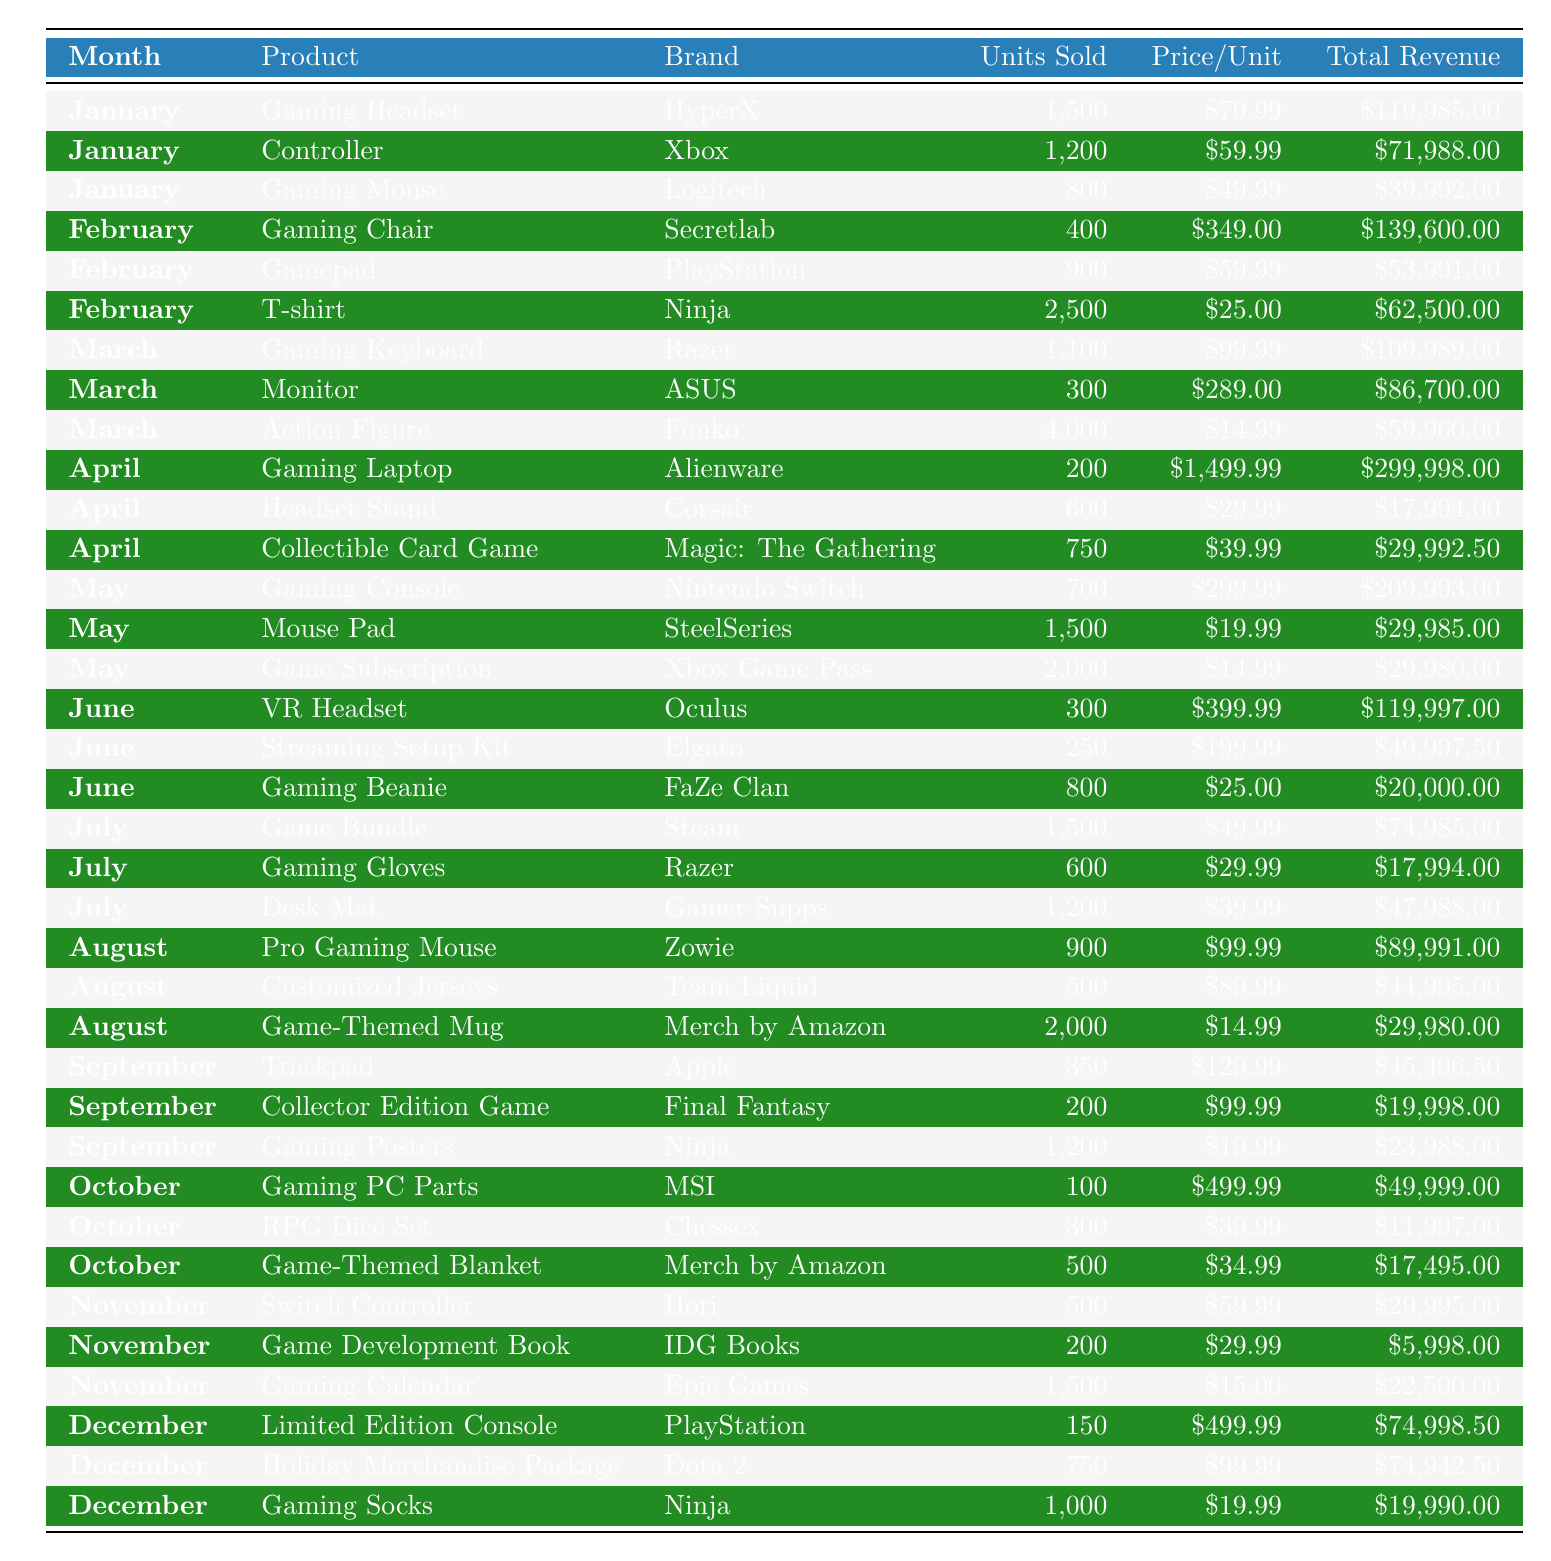What was the total revenue for Gaming Headset sales in January? The table shows that the total revenue for Gaming Headset sales in January is listed as $119,985.00.
Answer: $119,985.00 Which product had the highest total revenue in April? In April, the products listed with their total revenues are Gaming Laptop ($299,998.00), Headset Stand ($17,994.00), and Collectible Card Game ($29,992.50). The highest is the Gaming Laptop.
Answer: Gaming Laptop How many units of Gaming Console were sold in May? The table states that 700 units of the Gaming Console were sold in May.
Answer: 700 What is the total revenue from Gaming Beanie and VR Headset combined in June? The total revenue for Gaming Beanie is $20,000.00 and for VR Headset it is $119,997.00. Adding these gives $20,000.00 + $119,997.00 = $139,997.00.
Answer: $139,997.00 Did more units of Action Figures or Gaming Posters sell in March and September respectively? In March, 4,000 Action Figures were sold. In September, 1,200 Gaming Posters were sold. Since 4,000 is greater than 1,200, more Action Figures were sold.
Answer: Yes What is the average price per unit of Gaming Calendar and Limited Edition Console? The price per unit of Gaming Calendar is $15.00 and for Limited Edition Console it is $499.99. The average is ($15.00 + $499.99) / 2 = $257.50.
Answer: $257.50 Which month had the least total revenue and how much was it? By comparing the total revenues across all months, we find that November has the lowest total revenue (sum of all products: Switch Controller + Game Development Book + Gaming Calendar = $29,995.00 + $5,998.00 + $22,500.00 = $58,493.00).
Answer: November, $58,493.00 How much more total revenue did the Gaming Laptop generate compared to Gaming Headset in January? The total revenue for Gaming Laptop in April is $299,998.00, while for Gaming Headset in January it is $119,985.00. The difference is $299,998.00 - $119,985.00 = $180,013.00.
Answer: $180,013.00 What percentage of total revenue in December was generated from the Limited Edition Console? The total revenue from Limited Edition Console is $74,998.50, and the total revenue in December from all products is $74,998.50 + $74,942.50 + $19,990.00 = $169,931.00. The percentage is ($74,998.50 / $169,931.00) * 100 ≈ 44.1%.
Answer: 44.1% Which product in August had the lowest units sold, and how many were sold? In August, the products listed are Pro Gaming Mouse (900 units), Customized Jerseys (500 units), and Game-Themed Mug (2,000 units). The lowest is Customized Jerseys, with 500 units sold.
Answer: Customized Jerseys, 500 units 